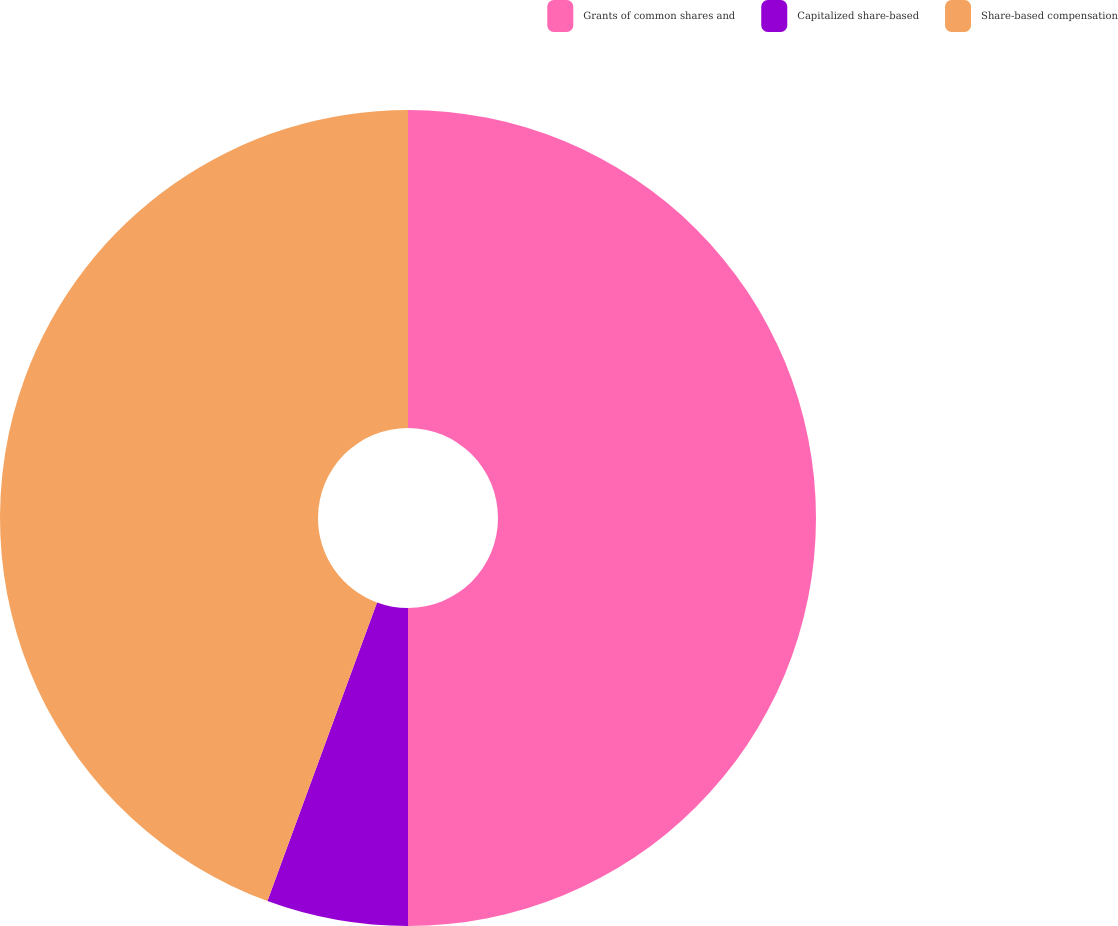<chart> <loc_0><loc_0><loc_500><loc_500><pie_chart><fcel>Grants of common shares and<fcel>Capitalized share-based<fcel>Share-based compensation<nl><fcel>50.0%<fcel>5.6%<fcel>44.4%<nl></chart> 